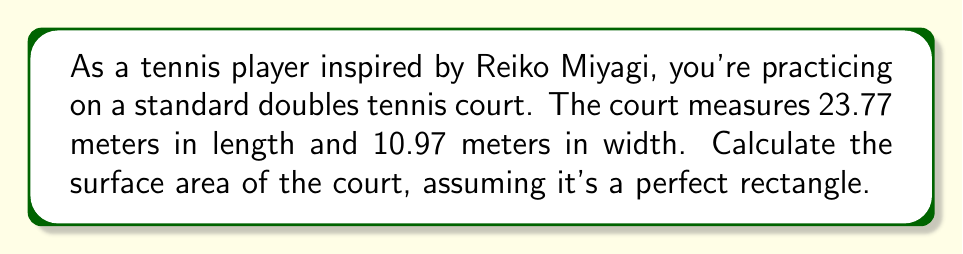Could you help me with this problem? To calculate the surface area of a rectangular tennis court, we need to multiply its length by its width. Let's break it down step-by-step:

1. Given dimensions:
   Length (l) = 23.77 meters
   Width (w) = 10.97 meters

2. The formula for the area of a rectangle is:
   $$A = l \times w$$

3. Substituting the values:
   $$A = 23.77 \text{ m} \times 10.97 \text{ m}$$

4. Performing the multiplication:
   $$A = 260.7569 \text{ m}^2$$

5. Rounding to two decimal places for practical purposes:
   $$A \approx 260.76 \text{ m}^2$$

Therefore, the surface area of the tennis court is approximately 260.76 square meters.
Answer: $260.76 \text{ m}^2$ 